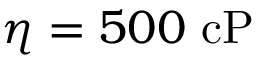<formula> <loc_0><loc_0><loc_500><loc_500>\eta = 5 0 0 c P</formula> 